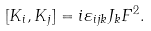<formula> <loc_0><loc_0><loc_500><loc_500>[ K _ { i } , K _ { j } ] = i \varepsilon _ { i j k } J _ { k } F ^ { 2 } .</formula> 